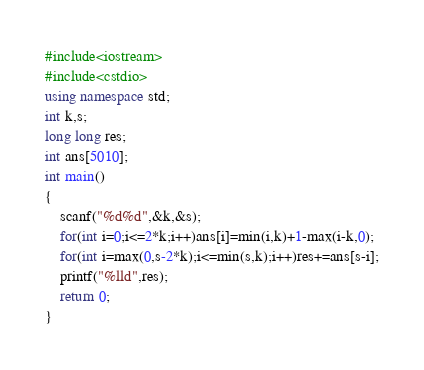Convert code to text. <code><loc_0><loc_0><loc_500><loc_500><_C++_>#include<iostream>
#include<cstdio>
using namespace std;
int k,s;
long long res;
int ans[5010];
int main()
{
	scanf("%d%d",&k,&s);
	for(int i=0;i<=2*k;i++)ans[i]=min(i,k)+1-max(i-k,0);
	for(int i=max(0,s-2*k);i<=min(s,k);i++)res+=ans[s-i];
	printf("%lld",res);
	return 0;
}</code> 